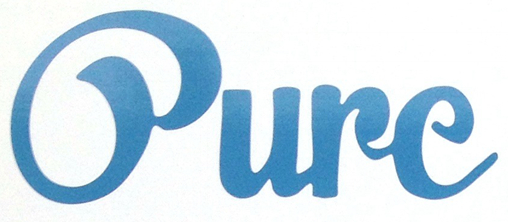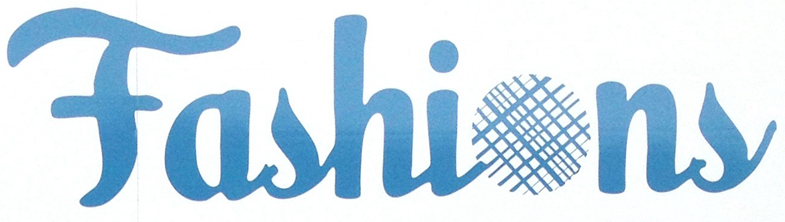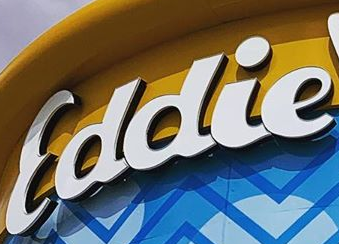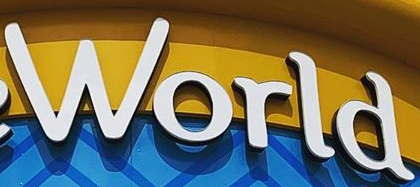What text appears in these images from left to right, separated by a semicolon? Oure; Fashions; Eddie; World 